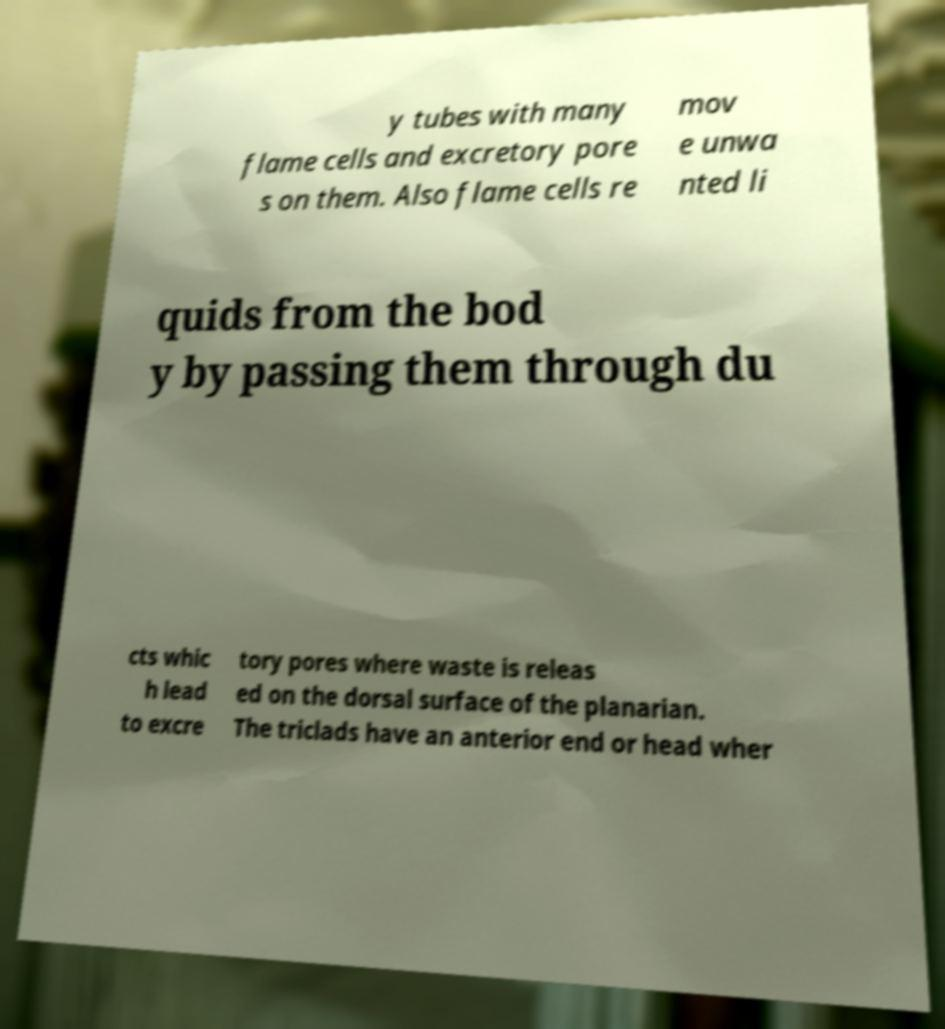Could you assist in decoding the text presented in this image and type it out clearly? y tubes with many flame cells and excretory pore s on them. Also flame cells re mov e unwa nted li quids from the bod y by passing them through du cts whic h lead to excre tory pores where waste is releas ed on the dorsal surface of the planarian. The triclads have an anterior end or head wher 